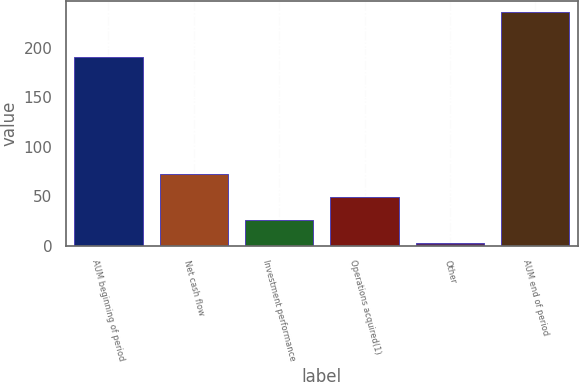<chart> <loc_0><loc_0><loc_500><loc_500><bar_chart><fcel>AUM beginning of period<fcel>Net cash flow<fcel>Investment performance<fcel>Operations acquired(1)<fcel>Other<fcel>AUM end of period<nl><fcel>191.4<fcel>72.62<fcel>25.94<fcel>49.28<fcel>2.6<fcel>236<nl></chart> 